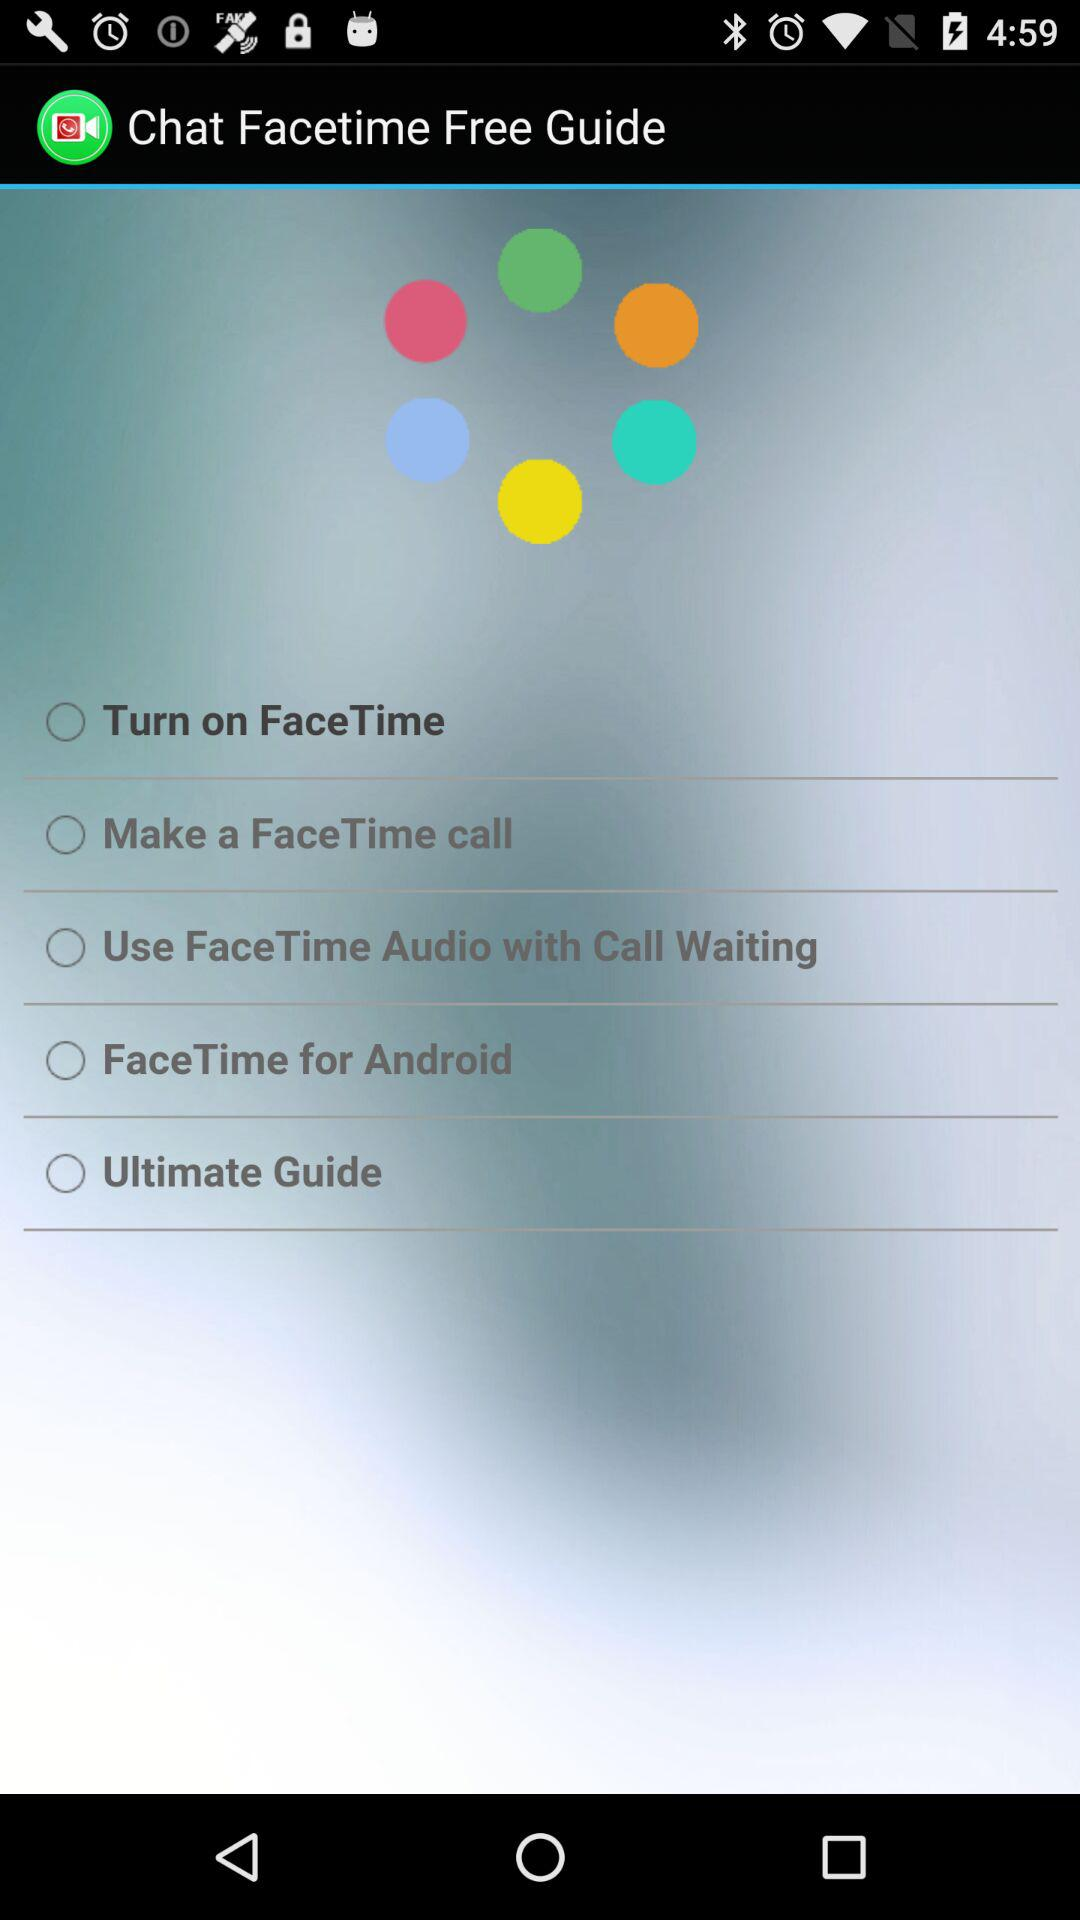What is the name of the application? The name of the application is "Chat Facetime Free Guide". 